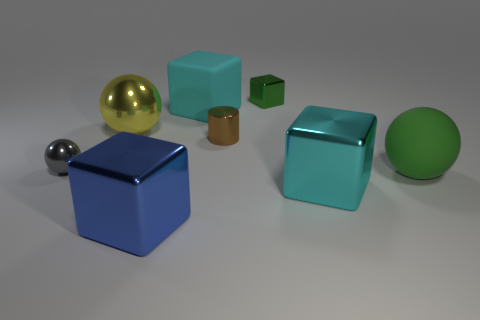Does the brown metal object have the same shape as the gray object?
Keep it short and to the point. No. Are there any green objects that are left of the large block that is in front of the big cyan cube right of the large cyan rubber block?
Ensure brevity in your answer.  No. What number of other things are there of the same color as the tiny block?
Provide a short and direct response. 1. Do the cyan block that is behind the gray sphere and the ball on the left side of the yellow object have the same size?
Provide a succinct answer. No. Is the number of cyan shiny cubes on the left side of the yellow ball the same as the number of gray metallic spheres that are behind the gray metallic ball?
Ensure brevity in your answer.  Yes. Are there any other things that are the same material as the blue block?
Make the answer very short. Yes. Is the size of the green rubber ball the same as the shiny cube behind the tiny shiny ball?
Give a very brief answer. No. What material is the large cyan cube that is to the right of the small green metallic block that is on the right side of the small gray metal object?
Make the answer very short. Metal. Are there the same number of metal spheres that are behind the yellow metallic object and large blocks?
Your answer should be very brief. No. What is the size of the sphere that is right of the small gray metal ball and behind the big green rubber thing?
Your answer should be very brief. Large. 